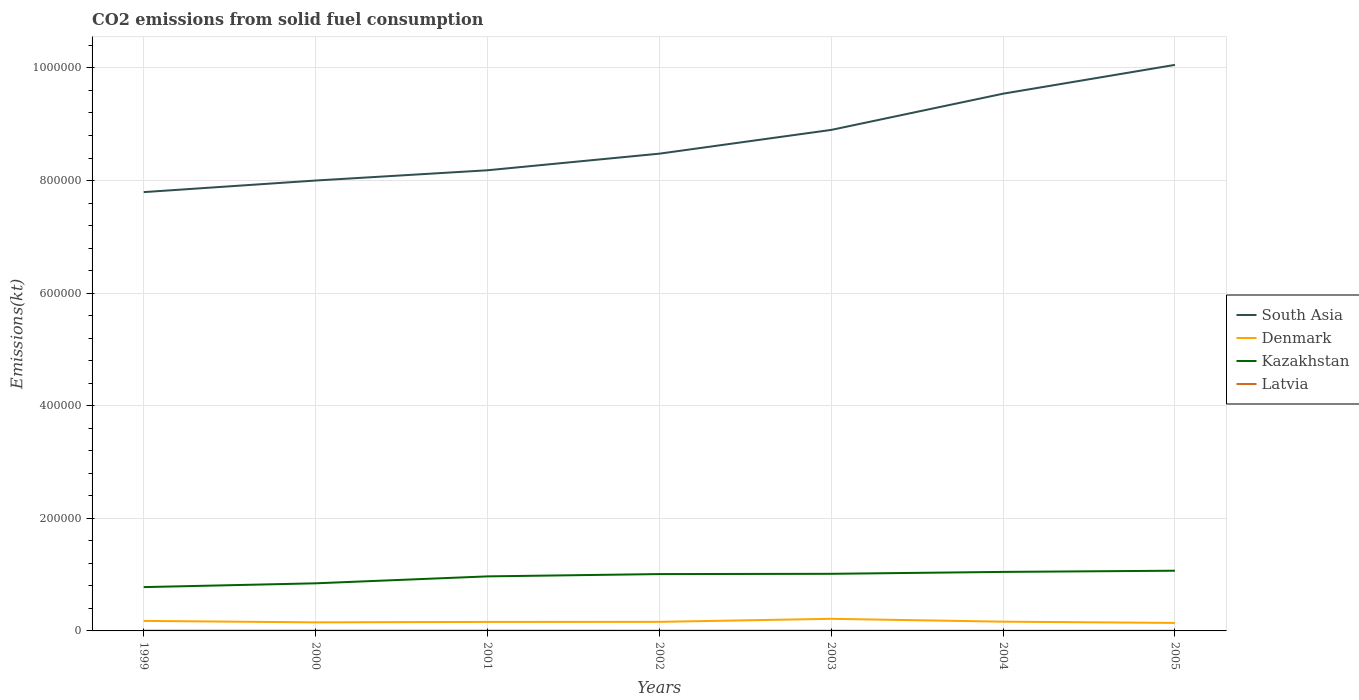How many different coloured lines are there?
Your response must be concise. 4. Does the line corresponding to Kazakhstan intersect with the line corresponding to Latvia?
Offer a terse response. No. Is the number of lines equal to the number of legend labels?
Offer a terse response. Yes. Across all years, what is the maximum amount of CO2 emitted in Kazakhstan?
Give a very brief answer. 7.78e+04. In which year was the amount of CO2 emitted in Denmark maximum?
Give a very brief answer. 2005. What is the total amount of CO2 emitted in Latvia in the graph?
Your response must be concise. 121.01. What is the difference between the highest and the second highest amount of CO2 emitted in Kazakhstan?
Ensure brevity in your answer.  2.91e+04. Is the amount of CO2 emitted in Denmark strictly greater than the amount of CO2 emitted in Kazakhstan over the years?
Keep it short and to the point. Yes. How many lines are there?
Make the answer very short. 4. What is the difference between two consecutive major ticks on the Y-axis?
Your response must be concise. 2.00e+05. How are the legend labels stacked?
Your response must be concise. Vertical. What is the title of the graph?
Keep it short and to the point. CO2 emissions from solid fuel consumption. What is the label or title of the Y-axis?
Your answer should be compact. Emissions(kt). What is the Emissions(kt) in South Asia in 1999?
Provide a short and direct response. 7.79e+05. What is the Emissions(kt) of Denmark in 1999?
Give a very brief answer. 1.78e+04. What is the Emissions(kt) in Kazakhstan in 1999?
Provide a succinct answer. 7.78e+04. What is the Emissions(kt) of Latvia in 1999?
Offer a very short reply. 480.38. What is the Emissions(kt) of South Asia in 2000?
Provide a succinct answer. 8.00e+05. What is the Emissions(kt) in Denmark in 2000?
Your answer should be compact. 1.52e+04. What is the Emissions(kt) in Kazakhstan in 2000?
Keep it short and to the point. 8.46e+04. What is the Emissions(kt) in Latvia in 2000?
Your response must be concise. 498.71. What is the Emissions(kt) in South Asia in 2001?
Offer a very short reply. 8.18e+05. What is the Emissions(kt) in Denmark in 2001?
Ensure brevity in your answer.  1.60e+04. What is the Emissions(kt) of Kazakhstan in 2001?
Provide a short and direct response. 9.69e+04. What is the Emissions(kt) in Latvia in 2001?
Give a very brief answer. 469.38. What is the Emissions(kt) in South Asia in 2002?
Your answer should be compact. 8.48e+05. What is the Emissions(kt) in Denmark in 2002?
Provide a succinct answer. 1.61e+04. What is the Emissions(kt) of Kazakhstan in 2002?
Ensure brevity in your answer.  1.01e+05. What is the Emissions(kt) in Latvia in 2002?
Give a very brief answer. 377.7. What is the Emissions(kt) of South Asia in 2003?
Your response must be concise. 8.90e+05. What is the Emissions(kt) in Denmark in 2003?
Give a very brief answer. 2.15e+04. What is the Emissions(kt) in Kazakhstan in 2003?
Provide a short and direct response. 1.01e+05. What is the Emissions(kt) in Latvia in 2003?
Your response must be concise. 330.03. What is the Emissions(kt) in South Asia in 2004?
Your response must be concise. 9.54e+05. What is the Emissions(kt) of Denmark in 2004?
Give a very brief answer. 1.64e+04. What is the Emissions(kt) in Kazakhstan in 2004?
Your response must be concise. 1.05e+05. What is the Emissions(kt) of Latvia in 2004?
Your answer should be compact. 256.69. What is the Emissions(kt) in South Asia in 2005?
Your response must be concise. 1.01e+06. What is the Emissions(kt) in Denmark in 2005?
Provide a succinct answer. 1.42e+04. What is the Emissions(kt) of Kazakhstan in 2005?
Give a very brief answer. 1.07e+05. What is the Emissions(kt) in Latvia in 2005?
Your answer should be compact. 311.69. Across all years, what is the maximum Emissions(kt) in South Asia?
Offer a very short reply. 1.01e+06. Across all years, what is the maximum Emissions(kt) in Denmark?
Offer a terse response. 2.15e+04. Across all years, what is the maximum Emissions(kt) of Kazakhstan?
Keep it short and to the point. 1.07e+05. Across all years, what is the maximum Emissions(kt) of Latvia?
Your answer should be very brief. 498.71. Across all years, what is the minimum Emissions(kt) of South Asia?
Offer a terse response. 7.79e+05. Across all years, what is the minimum Emissions(kt) of Denmark?
Your answer should be very brief. 1.42e+04. Across all years, what is the minimum Emissions(kt) in Kazakhstan?
Offer a very short reply. 7.78e+04. Across all years, what is the minimum Emissions(kt) of Latvia?
Make the answer very short. 256.69. What is the total Emissions(kt) of South Asia in the graph?
Keep it short and to the point. 6.10e+06. What is the total Emissions(kt) of Denmark in the graph?
Give a very brief answer. 1.17e+05. What is the total Emissions(kt) of Kazakhstan in the graph?
Provide a succinct answer. 6.73e+05. What is the total Emissions(kt) of Latvia in the graph?
Offer a terse response. 2724.58. What is the difference between the Emissions(kt) in South Asia in 1999 and that in 2000?
Provide a succinct answer. -2.06e+04. What is the difference between the Emissions(kt) of Denmark in 1999 and that in 2000?
Your answer should be very brief. 2592.57. What is the difference between the Emissions(kt) of Kazakhstan in 1999 and that in 2000?
Ensure brevity in your answer.  -6728.94. What is the difference between the Emissions(kt) in Latvia in 1999 and that in 2000?
Ensure brevity in your answer.  -18.34. What is the difference between the Emissions(kt) in South Asia in 1999 and that in 2001?
Make the answer very short. -3.88e+04. What is the difference between the Emissions(kt) of Denmark in 1999 and that in 2001?
Provide a succinct answer. 1826.17. What is the difference between the Emissions(kt) of Kazakhstan in 1999 and that in 2001?
Your answer should be compact. -1.90e+04. What is the difference between the Emissions(kt) in Latvia in 1999 and that in 2001?
Your response must be concise. 11. What is the difference between the Emissions(kt) of South Asia in 1999 and that in 2002?
Make the answer very short. -6.83e+04. What is the difference between the Emissions(kt) of Denmark in 1999 and that in 2002?
Offer a very short reply. 1679.49. What is the difference between the Emissions(kt) in Kazakhstan in 1999 and that in 2002?
Ensure brevity in your answer.  -2.31e+04. What is the difference between the Emissions(kt) in Latvia in 1999 and that in 2002?
Provide a short and direct response. 102.68. What is the difference between the Emissions(kt) in South Asia in 1999 and that in 2003?
Provide a succinct answer. -1.10e+05. What is the difference between the Emissions(kt) of Denmark in 1999 and that in 2003?
Provide a succinct answer. -3703.67. What is the difference between the Emissions(kt) of Kazakhstan in 1999 and that in 2003?
Offer a very short reply. -2.36e+04. What is the difference between the Emissions(kt) in Latvia in 1999 and that in 2003?
Make the answer very short. 150.35. What is the difference between the Emissions(kt) in South Asia in 1999 and that in 2004?
Your response must be concise. -1.75e+05. What is the difference between the Emissions(kt) of Denmark in 1999 and that in 2004?
Ensure brevity in your answer.  1364.12. What is the difference between the Emissions(kt) of Kazakhstan in 1999 and that in 2004?
Offer a very short reply. -2.70e+04. What is the difference between the Emissions(kt) of Latvia in 1999 and that in 2004?
Your response must be concise. 223.69. What is the difference between the Emissions(kt) in South Asia in 1999 and that in 2005?
Give a very brief answer. -2.26e+05. What is the difference between the Emissions(kt) in Denmark in 1999 and that in 2005?
Provide a short and direct response. 3600.99. What is the difference between the Emissions(kt) of Kazakhstan in 1999 and that in 2005?
Keep it short and to the point. -2.91e+04. What is the difference between the Emissions(kt) in Latvia in 1999 and that in 2005?
Your response must be concise. 168.68. What is the difference between the Emissions(kt) in South Asia in 2000 and that in 2001?
Provide a succinct answer. -1.82e+04. What is the difference between the Emissions(kt) of Denmark in 2000 and that in 2001?
Ensure brevity in your answer.  -766.4. What is the difference between the Emissions(kt) of Kazakhstan in 2000 and that in 2001?
Provide a short and direct response. -1.23e+04. What is the difference between the Emissions(kt) of Latvia in 2000 and that in 2001?
Provide a short and direct response. 29.34. What is the difference between the Emissions(kt) in South Asia in 2000 and that in 2002?
Give a very brief answer. -4.77e+04. What is the difference between the Emissions(kt) in Denmark in 2000 and that in 2002?
Give a very brief answer. -913.08. What is the difference between the Emissions(kt) of Kazakhstan in 2000 and that in 2002?
Your answer should be very brief. -1.64e+04. What is the difference between the Emissions(kt) of Latvia in 2000 and that in 2002?
Ensure brevity in your answer.  121.01. What is the difference between the Emissions(kt) in South Asia in 2000 and that in 2003?
Make the answer very short. -8.99e+04. What is the difference between the Emissions(kt) of Denmark in 2000 and that in 2003?
Keep it short and to the point. -6296.24. What is the difference between the Emissions(kt) of Kazakhstan in 2000 and that in 2003?
Offer a very short reply. -1.69e+04. What is the difference between the Emissions(kt) of Latvia in 2000 and that in 2003?
Your answer should be compact. 168.68. What is the difference between the Emissions(kt) of South Asia in 2000 and that in 2004?
Your response must be concise. -1.54e+05. What is the difference between the Emissions(kt) of Denmark in 2000 and that in 2004?
Offer a very short reply. -1228.44. What is the difference between the Emissions(kt) of Kazakhstan in 2000 and that in 2004?
Your response must be concise. -2.03e+04. What is the difference between the Emissions(kt) of Latvia in 2000 and that in 2004?
Offer a terse response. 242.02. What is the difference between the Emissions(kt) of South Asia in 2000 and that in 2005?
Ensure brevity in your answer.  -2.05e+05. What is the difference between the Emissions(kt) of Denmark in 2000 and that in 2005?
Your response must be concise. 1008.42. What is the difference between the Emissions(kt) in Kazakhstan in 2000 and that in 2005?
Make the answer very short. -2.24e+04. What is the difference between the Emissions(kt) in Latvia in 2000 and that in 2005?
Provide a short and direct response. 187.02. What is the difference between the Emissions(kt) in South Asia in 2001 and that in 2002?
Your answer should be compact. -2.95e+04. What is the difference between the Emissions(kt) of Denmark in 2001 and that in 2002?
Provide a short and direct response. -146.68. What is the difference between the Emissions(kt) in Kazakhstan in 2001 and that in 2002?
Make the answer very short. -4092.37. What is the difference between the Emissions(kt) of Latvia in 2001 and that in 2002?
Provide a short and direct response. 91.67. What is the difference between the Emissions(kt) of South Asia in 2001 and that in 2003?
Offer a very short reply. -7.17e+04. What is the difference between the Emissions(kt) in Denmark in 2001 and that in 2003?
Your answer should be compact. -5529.84. What is the difference between the Emissions(kt) of Kazakhstan in 2001 and that in 2003?
Make the answer very short. -4558.08. What is the difference between the Emissions(kt) in Latvia in 2001 and that in 2003?
Keep it short and to the point. 139.35. What is the difference between the Emissions(kt) of South Asia in 2001 and that in 2004?
Make the answer very short. -1.36e+05. What is the difference between the Emissions(kt) in Denmark in 2001 and that in 2004?
Your response must be concise. -462.04. What is the difference between the Emissions(kt) of Kazakhstan in 2001 and that in 2004?
Make the answer very short. -7950.06. What is the difference between the Emissions(kt) in Latvia in 2001 and that in 2004?
Your answer should be compact. 212.69. What is the difference between the Emissions(kt) in South Asia in 2001 and that in 2005?
Make the answer very short. -1.87e+05. What is the difference between the Emissions(kt) in Denmark in 2001 and that in 2005?
Provide a succinct answer. 1774.83. What is the difference between the Emissions(kt) in Kazakhstan in 2001 and that in 2005?
Give a very brief answer. -1.01e+04. What is the difference between the Emissions(kt) of Latvia in 2001 and that in 2005?
Offer a terse response. 157.68. What is the difference between the Emissions(kt) in South Asia in 2002 and that in 2003?
Your answer should be very brief. -4.22e+04. What is the difference between the Emissions(kt) of Denmark in 2002 and that in 2003?
Offer a terse response. -5383.16. What is the difference between the Emissions(kt) of Kazakhstan in 2002 and that in 2003?
Provide a succinct answer. -465.71. What is the difference between the Emissions(kt) in Latvia in 2002 and that in 2003?
Ensure brevity in your answer.  47.67. What is the difference between the Emissions(kt) of South Asia in 2002 and that in 2004?
Offer a terse response. -1.07e+05. What is the difference between the Emissions(kt) in Denmark in 2002 and that in 2004?
Offer a very short reply. -315.36. What is the difference between the Emissions(kt) of Kazakhstan in 2002 and that in 2004?
Provide a succinct answer. -3857.68. What is the difference between the Emissions(kt) of Latvia in 2002 and that in 2004?
Ensure brevity in your answer.  121.01. What is the difference between the Emissions(kt) in South Asia in 2002 and that in 2005?
Make the answer very short. -1.58e+05. What is the difference between the Emissions(kt) of Denmark in 2002 and that in 2005?
Provide a succinct answer. 1921.51. What is the difference between the Emissions(kt) in Kazakhstan in 2002 and that in 2005?
Provide a short and direct response. -5966.21. What is the difference between the Emissions(kt) of Latvia in 2002 and that in 2005?
Make the answer very short. 66.01. What is the difference between the Emissions(kt) of South Asia in 2003 and that in 2004?
Keep it short and to the point. -6.43e+04. What is the difference between the Emissions(kt) of Denmark in 2003 and that in 2004?
Your answer should be very brief. 5067.79. What is the difference between the Emissions(kt) in Kazakhstan in 2003 and that in 2004?
Your response must be concise. -3391.97. What is the difference between the Emissions(kt) in Latvia in 2003 and that in 2004?
Keep it short and to the point. 73.34. What is the difference between the Emissions(kt) of South Asia in 2003 and that in 2005?
Offer a very short reply. -1.16e+05. What is the difference between the Emissions(kt) of Denmark in 2003 and that in 2005?
Your answer should be compact. 7304.66. What is the difference between the Emissions(kt) of Kazakhstan in 2003 and that in 2005?
Offer a terse response. -5500.5. What is the difference between the Emissions(kt) of Latvia in 2003 and that in 2005?
Your answer should be very brief. 18.34. What is the difference between the Emissions(kt) of South Asia in 2004 and that in 2005?
Your response must be concise. -5.12e+04. What is the difference between the Emissions(kt) of Denmark in 2004 and that in 2005?
Offer a terse response. 2236.87. What is the difference between the Emissions(kt) in Kazakhstan in 2004 and that in 2005?
Provide a succinct answer. -2108.53. What is the difference between the Emissions(kt) in Latvia in 2004 and that in 2005?
Offer a terse response. -55.01. What is the difference between the Emissions(kt) in South Asia in 1999 and the Emissions(kt) in Denmark in 2000?
Your response must be concise. 7.64e+05. What is the difference between the Emissions(kt) of South Asia in 1999 and the Emissions(kt) of Kazakhstan in 2000?
Your answer should be compact. 6.95e+05. What is the difference between the Emissions(kt) of South Asia in 1999 and the Emissions(kt) of Latvia in 2000?
Your answer should be very brief. 7.79e+05. What is the difference between the Emissions(kt) in Denmark in 1999 and the Emissions(kt) in Kazakhstan in 2000?
Make the answer very short. -6.68e+04. What is the difference between the Emissions(kt) of Denmark in 1999 and the Emissions(kt) of Latvia in 2000?
Offer a terse response. 1.73e+04. What is the difference between the Emissions(kt) in Kazakhstan in 1999 and the Emissions(kt) in Latvia in 2000?
Provide a short and direct response. 7.73e+04. What is the difference between the Emissions(kt) of South Asia in 1999 and the Emissions(kt) of Denmark in 2001?
Your answer should be compact. 7.64e+05. What is the difference between the Emissions(kt) of South Asia in 1999 and the Emissions(kt) of Kazakhstan in 2001?
Your answer should be compact. 6.83e+05. What is the difference between the Emissions(kt) in South Asia in 1999 and the Emissions(kt) in Latvia in 2001?
Offer a very short reply. 7.79e+05. What is the difference between the Emissions(kt) in Denmark in 1999 and the Emissions(kt) in Kazakhstan in 2001?
Keep it short and to the point. -7.91e+04. What is the difference between the Emissions(kt) of Denmark in 1999 and the Emissions(kt) of Latvia in 2001?
Keep it short and to the point. 1.73e+04. What is the difference between the Emissions(kt) in Kazakhstan in 1999 and the Emissions(kt) in Latvia in 2001?
Provide a succinct answer. 7.74e+04. What is the difference between the Emissions(kt) in South Asia in 1999 and the Emissions(kt) in Denmark in 2002?
Your answer should be compact. 7.63e+05. What is the difference between the Emissions(kt) of South Asia in 1999 and the Emissions(kt) of Kazakhstan in 2002?
Give a very brief answer. 6.79e+05. What is the difference between the Emissions(kt) in South Asia in 1999 and the Emissions(kt) in Latvia in 2002?
Offer a very short reply. 7.79e+05. What is the difference between the Emissions(kt) of Denmark in 1999 and the Emissions(kt) of Kazakhstan in 2002?
Give a very brief answer. -8.32e+04. What is the difference between the Emissions(kt) in Denmark in 1999 and the Emissions(kt) in Latvia in 2002?
Offer a terse response. 1.74e+04. What is the difference between the Emissions(kt) of Kazakhstan in 1999 and the Emissions(kt) of Latvia in 2002?
Offer a terse response. 7.75e+04. What is the difference between the Emissions(kt) of South Asia in 1999 and the Emissions(kt) of Denmark in 2003?
Offer a very short reply. 7.58e+05. What is the difference between the Emissions(kt) of South Asia in 1999 and the Emissions(kt) of Kazakhstan in 2003?
Offer a very short reply. 6.78e+05. What is the difference between the Emissions(kt) in South Asia in 1999 and the Emissions(kt) in Latvia in 2003?
Your answer should be very brief. 7.79e+05. What is the difference between the Emissions(kt) of Denmark in 1999 and the Emissions(kt) of Kazakhstan in 2003?
Give a very brief answer. -8.36e+04. What is the difference between the Emissions(kt) in Denmark in 1999 and the Emissions(kt) in Latvia in 2003?
Your response must be concise. 1.75e+04. What is the difference between the Emissions(kt) in Kazakhstan in 1999 and the Emissions(kt) in Latvia in 2003?
Your answer should be very brief. 7.75e+04. What is the difference between the Emissions(kt) of South Asia in 1999 and the Emissions(kt) of Denmark in 2004?
Offer a terse response. 7.63e+05. What is the difference between the Emissions(kt) in South Asia in 1999 and the Emissions(kt) in Kazakhstan in 2004?
Make the answer very short. 6.75e+05. What is the difference between the Emissions(kt) in South Asia in 1999 and the Emissions(kt) in Latvia in 2004?
Offer a terse response. 7.79e+05. What is the difference between the Emissions(kt) of Denmark in 1999 and the Emissions(kt) of Kazakhstan in 2004?
Provide a succinct answer. -8.70e+04. What is the difference between the Emissions(kt) in Denmark in 1999 and the Emissions(kt) in Latvia in 2004?
Your answer should be compact. 1.75e+04. What is the difference between the Emissions(kt) in Kazakhstan in 1999 and the Emissions(kt) in Latvia in 2004?
Offer a terse response. 7.76e+04. What is the difference between the Emissions(kt) in South Asia in 1999 and the Emissions(kt) in Denmark in 2005?
Your response must be concise. 7.65e+05. What is the difference between the Emissions(kt) in South Asia in 1999 and the Emissions(kt) in Kazakhstan in 2005?
Offer a terse response. 6.73e+05. What is the difference between the Emissions(kt) of South Asia in 1999 and the Emissions(kt) of Latvia in 2005?
Your response must be concise. 7.79e+05. What is the difference between the Emissions(kt) of Denmark in 1999 and the Emissions(kt) of Kazakhstan in 2005?
Provide a succinct answer. -8.91e+04. What is the difference between the Emissions(kt) of Denmark in 1999 and the Emissions(kt) of Latvia in 2005?
Make the answer very short. 1.75e+04. What is the difference between the Emissions(kt) of Kazakhstan in 1999 and the Emissions(kt) of Latvia in 2005?
Give a very brief answer. 7.75e+04. What is the difference between the Emissions(kt) in South Asia in 2000 and the Emissions(kt) in Denmark in 2001?
Offer a very short reply. 7.84e+05. What is the difference between the Emissions(kt) of South Asia in 2000 and the Emissions(kt) of Kazakhstan in 2001?
Offer a very short reply. 7.03e+05. What is the difference between the Emissions(kt) in South Asia in 2000 and the Emissions(kt) in Latvia in 2001?
Give a very brief answer. 8.00e+05. What is the difference between the Emissions(kt) in Denmark in 2000 and the Emissions(kt) in Kazakhstan in 2001?
Keep it short and to the point. -8.17e+04. What is the difference between the Emissions(kt) in Denmark in 2000 and the Emissions(kt) in Latvia in 2001?
Your response must be concise. 1.47e+04. What is the difference between the Emissions(kt) of Kazakhstan in 2000 and the Emissions(kt) of Latvia in 2001?
Offer a very short reply. 8.41e+04. What is the difference between the Emissions(kt) of South Asia in 2000 and the Emissions(kt) of Denmark in 2002?
Your answer should be compact. 7.84e+05. What is the difference between the Emissions(kt) of South Asia in 2000 and the Emissions(kt) of Kazakhstan in 2002?
Keep it short and to the point. 6.99e+05. What is the difference between the Emissions(kt) of South Asia in 2000 and the Emissions(kt) of Latvia in 2002?
Offer a very short reply. 8.00e+05. What is the difference between the Emissions(kt) in Denmark in 2000 and the Emissions(kt) in Kazakhstan in 2002?
Provide a short and direct response. -8.58e+04. What is the difference between the Emissions(kt) in Denmark in 2000 and the Emissions(kt) in Latvia in 2002?
Make the answer very short. 1.48e+04. What is the difference between the Emissions(kt) in Kazakhstan in 2000 and the Emissions(kt) in Latvia in 2002?
Make the answer very short. 8.42e+04. What is the difference between the Emissions(kt) of South Asia in 2000 and the Emissions(kt) of Denmark in 2003?
Your response must be concise. 7.79e+05. What is the difference between the Emissions(kt) in South Asia in 2000 and the Emissions(kt) in Kazakhstan in 2003?
Your answer should be very brief. 6.99e+05. What is the difference between the Emissions(kt) of South Asia in 2000 and the Emissions(kt) of Latvia in 2003?
Make the answer very short. 8.00e+05. What is the difference between the Emissions(kt) in Denmark in 2000 and the Emissions(kt) in Kazakhstan in 2003?
Your answer should be very brief. -8.62e+04. What is the difference between the Emissions(kt) in Denmark in 2000 and the Emissions(kt) in Latvia in 2003?
Make the answer very short. 1.49e+04. What is the difference between the Emissions(kt) of Kazakhstan in 2000 and the Emissions(kt) of Latvia in 2003?
Your answer should be compact. 8.42e+04. What is the difference between the Emissions(kt) in South Asia in 2000 and the Emissions(kt) in Denmark in 2004?
Your answer should be very brief. 7.84e+05. What is the difference between the Emissions(kt) of South Asia in 2000 and the Emissions(kt) of Kazakhstan in 2004?
Offer a very short reply. 6.95e+05. What is the difference between the Emissions(kt) in South Asia in 2000 and the Emissions(kt) in Latvia in 2004?
Provide a succinct answer. 8.00e+05. What is the difference between the Emissions(kt) of Denmark in 2000 and the Emissions(kt) of Kazakhstan in 2004?
Ensure brevity in your answer.  -8.96e+04. What is the difference between the Emissions(kt) in Denmark in 2000 and the Emissions(kt) in Latvia in 2004?
Your response must be concise. 1.50e+04. What is the difference between the Emissions(kt) of Kazakhstan in 2000 and the Emissions(kt) of Latvia in 2004?
Give a very brief answer. 8.43e+04. What is the difference between the Emissions(kt) in South Asia in 2000 and the Emissions(kt) in Denmark in 2005?
Keep it short and to the point. 7.86e+05. What is the difference between the Emissions(kt) in South Asia in 2000 and the Emissions(kt) in Kazakhstan in 2005?
Give a very brief answer. 6.93e+05. What is the difference between the Emissions(kt) of South Asia in 2000 and the Emissions(kt) of Latvia in 2005?
Make the answer very short. 8.00e+05. What is the difference between the Emissions(kt) of Denmark in 2000 and the Emissions(kt) of Kazakhstan in 2005?
Ensure brevity in your answer.  -9.17e+04. What is the difference between the Emissions(kt) of Denmark in 2000 and the Emissions(kt) of Latvia in 2005?
Provide a short and direct response. 1.49e+04. What is the difference between the Emissions(kt) in Kazakhstan in 2000 and the Emissions(kt) in Latvia in 2005?
Give a very brief answer. 8.43e+04. What is the difference between the Emissions(kt) in South Asia in 2001 and the Emissions(kt) in Denmark in 2002?
Make the answer very short. 8.02e+05. What is the difference between the Emissions(kt) of South Asia in 2001 and the Emissions(kt) of Kazakhstan in 2002?
Ensure brevity in your answer.  7.17e+05. What is the difference between the Emissions(kt) in South Asia in 2001 and the Emissions(kt) in Latvia in 2002?
Give a very brief answer. 8.18e+05. What is the difference between the Emissions(kt) in Denmark in 2001 and the Emissions(kt) in Kazakhstan in 2002?
Keep it short and to the point. -8.50e+04. What is the difference between the Emissions(kt) in Denmark in 2001 and the Emissions(kt) in Latvia in 2002?
Ensure brevity in your answer.  1.56e+04. What is the difference between the Emissions(kt) of Kazakhstan in 2001 and the Emissions(kt) of Latvia in 2002?
Make the answer very short. 9.65e+04. What is the difference between the Emissions(kt) in South Asia in 2001 and the Emissions(kt) in Denmark in 2003?
Your answer should be compact. 7.97e+05. What is the difference between the Emissions(kt) in South Asia in 2001 and the Emissions(kt) in Kazakhstan in 2003?
Provide a short and direct response. 7.17e+05. What is the difference between the Emissions(kt) in South Asia in 2001 and the Emissions(kt) in Latvia in 2003?
Provide a succinct answer. 8.18e+05. What is the difference between the Emissions(kt) of Denmark in 2001 and the Emissions(kt) of Kazakhstan in 2003?
Offer a very short reply. -8.55e+04. What is the difference between the Emissions(kt) in Denmark in 2001 and the Emissions(kt) in Latvia in 2003?
Make the answer very short. 1.56e+04. What is the difference between the Emissions(kt) of Kazakhstan in 2001 and the Emissions(kt) of Latvia in 2003?
Offer a very short reply. 9.65e+04. What is the difference between the Emissions(kt) in South Asia in 2001 and the Emissions(kt) in Denmark in 2004?
Your response must be concise. 8.02e+05. What is the difference between the Emissions(kt) of South Asia in 2001 and the Emissions(kt) of Kazakhstan in 2004?
Provide a short and direct response. 7.13e+05. What is the difference between the Emissions(kt) in South Asia in 2001 and the Emissions(kt) in Latvia in 2004?
Ensure brevity in your answer.  8.18e+05. What is the difference between the Emissions(kt) in Denmark in 2001 and the Emissions(kt) in Kazakhstan in 2004?
Make the answer very short. -8.89e+04. What is the difference between the Emissions(kt) of Denmark in 2001 and the Emissions(kt) of Latvia in 2004?
Offer a very short reply. 1.57e+04. What is the difference between the Emissions(kt) in Kazakhstan in 2001 and the Emissions(kt) in Latvia in 2004?
Offer a very short reply. 9.66e+04. What is the difference between the Emissions(kt) of South Asia in 2001 and the Emissions(kt) of Denmark in 2005?
Your answer should be compact. 8.04e+05. What is the difference between the Emissions(kt) in South Asia in 2001 and the Emissions(kt) in Kazakhstan in 2005?
Offer a very short reply. 7.11e+05. What is the difference between the Emissions(kt) of South Asia in 2001 and the Emissions(kt) of Latvia in 2005?
Offer a very short reply. 8.18e+05. What is the difference between the Emissions(kt) of Denmark in 2001 and the Emissions(kt) of Kazakhstan in 2005?
Give a very brief answer. -9.10e+04. What is the difference between the Emissions(kt) in Denmark in 2001 and the Emissions(kt) in Latvia in 2005?
Ensure brevity in your answer.  1.57e+04. What is the difference between the Emissions(kt) of Kazakhstan in 2001 and the Emissions(kt) of Latvia in 2005?
Provide a short and direct response. 9.66e+04. What is the difference between the Emissions(kt) in South Asia in 2002 and the Emissions(kt) in Denmark in 2003?
Ensure brevity in your answer.  8.26e+05. What is the difference between the Emissions(kt) in South Asia in 2002 and the Emissions(kt) in Kazakhstan in 2003?
Give a very brief answer. 7.46e+05. What is the difference between the Emissions(kt) of South Asia in 2002 and the Emissions(kt) of Latvia in 2003?
Provide a short and direct response. 8.47e+05. What is the difference between the Emissions(kt) in Denmark in 2002 and the Emissions(kt) in Kazakhstan in 2003?
Give a very brief answer. -8.53e+04. What is the difference between the Emissions(kt) in Denmark in 2002 and the Emissions(kt) in Latvia in 2003?
Make the answer very short. 1.58e+04. What is the difference between the Emissions(kt) of Kazakhstan in 2002 and the Emissions(kt) of Latvia in 2003?
Offer a terse response. 1.01e+05. What is the difference between the Emissions(kt) of South Asia in 2002 and the Emissions(kt) of Denmark in 2004?
Your response must be concise. 8.31e+05. What is the difference between the Emissions(kt) in South Asia in 2002 and the Emissions(kt) in Kazakhstan in 2004?
Your response must be concise. 7.43e+05. What is the difference between the Emissions(kt) of South Asia in 2002 and the Emissions(kt) of Latvia in 2004?
Provide a short and direct response. 8.47e+05. What is the difference between the Emissions(kt) of Denmark in 2002 and the Emissions(kt) of Kazakhstan in 2004?
Keep it short and to the point. -8.87e+04. What is the difference between the Emissions(kt) of Denmark in 2002 and the Emissions(kt) of Latvia in 2004?
Your answer should be very brief. 1.59e+04. What is the difference between the Emissions(kt) in Kazakhstan in 2002 and the Emissions(kt) in Latvia in 2004?
Ensure brevity in your answer.  1.01e+05. What is the difference between the Emissions(kt) in South Asia in 2002 and the Emissions(kt) in Denmark in 2005?
Provide a succinct answer. 8.34e+05. What is the difference between the Emissions(kt) of South Asia in 2002 and the Emissions(kt) of Kazakhstan in 2005?
Make the answer very short. 7.41e+05. What is the difference between the Emissions(kt) of South Asia in 2002 and the Emissions(kt) of Latvia in 2005?
Your answer should be compact. 8.47e+05. What is the difference between the Emissions(kt) of Denmark in 2002 and the Emissions(kt) of Kazakhstan in 2005?
Provide a short and direct response. -9.08e+04. What is the difference between the Emissions(kt) in Denmark in 2002 and the Emissions(kt) in Latvia in 2005?
Ensure brevity in your answer.  1.58e+04. What is the difference between the Emissions(kt) in Kazakhstan in 2002 and the Emissions(kt) in Latvia in 2005?
Ensure brevity in your answer.  1.01e+05. What is the difference between the Emissions(kt) in South Asia in 2003 and the Emissions(kt) in Denmark in 2004?
Give a very brief answer. 8.74e+05. What is the difference between the Emissions(kt) of South Asia in 2003 and the Emissions(kt) of Kazakhstan in 2004?
Keep it short and to the point. 7.85e+05. What is the difference between the Emissions(kt) of South Asia in 2003 and the Emissions(kt) of Latvia in 2004?
Provide a short and direct response. 8.90e+05. What is the difference between the Emissions(kt) in Denmark in 2003 and the Emissions(kt) in Kazakhstan in 2004?
Provide a short and direct response. -8.33e+04. What is the difference between the Emissions(kt) of Denmark in 2003 and the Emissions(kt) of Latvia in 2004?
Make the answer very short. 2.12e+04. What is the difference between the Emissions(kt) in Kazakhstan in 2003 and the Emissions(kt) in Latvia in 2004?
Make the answer very short. 1.01e+05. What is the difference between the Emissions(kt) in South Asia in 2003 and the Emissions(kt) in Denmark in 2005?
Make the answer very short. 8.76e+05. What is the difference between the Emissions(kt) of South Asia in 2003 and the Emissions(kt) of Kazakhstan in 2005?
Give a very brief answer. 7.83e+05. What is the difference between the Emissions(kt) of South Asia in 2003 and the Emissions(kt) of Latvia in 2005?
Your answer should be very brief. 8.90e+05. What is the difference between the Emissions(kt) of Denmark in 2003 and the Emissions(kt) of Kazakhstan in 2005?
Ensure brevity in your answer.  -8.54e+04. What is the difference between the Emissions(kt) of Denmark in 2003 and the Emissions(kt) of Latvia in 2005?
Ensure brevity in your answer.  2.12e+04. What is the difference between the Emissions(kt) in Kazakhstan in 2003 and the Emissions(kt) in Latvia in 2005?
Your answer should be very brief. 1.01e+05. What is the difference between the Emissions(kt) of South Asia in 2004 and the Emissions(kt) of Denmark in 2005?
Make the answer very short. 9.40e+05. What is the difference between the Emissions(kt) of South Asia in 2004 and the Emissions(kt) of Kazakhstan in 2005?
Your response must be concise. 8.47e+05. What is the difference between the Emissions(kt) in South Asia in 2004 and the Emissions(kt) in Latvia in 2005?
Provide a short and direct response. 9.54e+05. What is the difference between the Emissions(kt) in Denmark in 2004 and the Emissions(kt) in Kazakhstan in 2005?
Keep it short and to the point. -9.05e+04. What is the difference between the Emissions(kt) in Denmark in 2004 and the Emissions(kt) in Latvia in 2005?
Provide a succinct answer. 1.61e+04. What is the difference between the Emissions(kt) of Kazakhstan in 2004 and the Emissions(kt) of Latvia in 2005?
Make the answer very short. 1.05e+05. What is the average Emissions(kt) in South Asia per year?
Offer a terse response. 8.71e+05. What is the average Emissions(kt) of Denmark per year?
Make the answer very short. 1.67e+04. What is the average Emissions(kt) in Kazakhstan per year?
Your response must be concise. 9.62e+04. What is the average Emissions(kt) in Latvia per year?
Ensure brevity in your answer.  389.23. In the year 1999, what is the difference between the Emissions(kt) of South Asia and Emissions(kt) of Denmark?
Give a very brief answer. 7.62e+05. In the year 1999, what is the difference between the Emissions(kt) of South Asia and Emissions(kt) of Kazakhstan?
Offer a terse response. 7.02e+05. In the year 1999, what is the difference between the Emissions(kt) in South Asia and Emissions(kt) in Latvia?
Ensure brevity in your answer.  7.79e+05. In the year 1999, what is the difference between the Emissions(kt) in Denmark and Emissions(kt) in Kazakhstan?
Keep it short and to the point. -6.00e+04. In the year 1999, what is the difference between the Emissions(kt) of Denmark and Emissions(kt) of Latvia?
Give a very brief answer. 1.73e+04. In the year 1999, what is the difference between the Emissions(kt) of Kazakhstan and Emissions(kt) of Latvia?
Give a very brief answer. 7.74e+04. In the year 2000, what is the difference between the Emissions(kt) of South Asia and Emissions(kt) of Denmark?
Offer a terse response. 7.85e+05. In the year 2000, what is the difference between the Emissions(kt) of South Asia and Emissions(kt) of Kazakhstan?
Provide a short and direct response. 7.15e+05. In the year 2000, what is the difference between the Emissions(kt) in South Asia and Emissions(kt) in Latvia?
Your response must be concise. 8.00e+05. In the year 2000, what is the difference between the Emissions(kt) in Denmark and Emissions(kt) in Kazakhstan?
Keep it short and to the point. -6.94e+04. In the year 2000, what is the difference between the Emissions(kt) in Denmark and Emissions(kt) in Latvia?
Your answer should be compact. 1.47e+04. In the year 2000, what is the difference between the Emissions(kt) in Kazakhstan and Emissions(kt) in Latvia?
Your answer should be compact. 8.41e+04. In the year 2001, what is the difference between the Emissions(kt) in South Asia and Emissions(kt) in Denmark?
Provide a succinct answer. 8.02e+05. In the year 2001, what is the difference between the Emissions(kt) in South Asia and Emissions(kt) in Kazakhstan?
Ensure brevity in your answer.  7.21e+05. In the year 2001, what is the difference between the Emissions(kt) in South Asia and Emissions(kt) in Latvia?
Your answer should be compact. 8.18e+05. In the year 2001, what is the difference between the Emissions(kt) in Denmark and Emissions(kt) in Kazakhstan?
Provide a succinct answer. -8.09e+04. In the year 2001, what is the difference between the Emissions(kt) of Denmark and Emissions(kt) of Latvia?
Give a very brief answer. 1.55e+04. In the year 2001, what is the difference between the Emissions(kt) of Kazakhstan and Emissions(kt) of Latvia?
Your response must be concise. 9.64e+04. In the year 2002, what is the difference between the Emissions(kt) of South Asia and Emissions(kt) of Denmark?
Ensure brevity in your answer.  8.32e+05. In the year 2002, what is the difference between the Emissions(kt) of South Asia and Emissions(kt) of Kazakhstan?
Your answer should be very brief. 7.47e+05. In the year 2002, what is the difference between the Emissions(kt) of South Asia and Emissions(kt) of Latvia?
Provide a short and direct response. 8.47e+05. In the year 2002, what is the difference between the Emissions(kt) in Denmark and Emissions(kt) in Kazakhstan?
Make the answer very short. -8.49e+04. In the year 2002, what is the difference between the Emissions(kt) of Denmark and Emissions(kt) of Latvia?
Your answer should be very brief. 1.57e+04. In the year 2002, what is the difference between the Emissions(kt) of Kazakhstan and Emissions(kt) of Latvia?
Give a very brief answer. 1.01e+05. In the year 2003, what is the difference between the Emissions(kt) in South Asia and Emissions(kt) in Denmark?
Ensure brevity in your answer.  8.68e+05. In the year 2003, what is the difference between the Emissions(kt) in South Asia and Emissions(kt) in Kazakhstan?
Provide a short and direct response. 7.89e+05. In the year 2003, what is the difference between the Emissions(kt) in South Asia and Emissions(kt) in Latvia?
Your answer should be very brief. 8.90e+05. In the year 2003, what is the difference between the Emissions(kt) in Denmark and Emissions(kt) in Kazakhstan?
Provide a succinct answer. -7.99e+04. In the year 2003, what is the difference between the Emissions(kt) in Denmark and Emissions(kt) in Latvia?
Ensure brevity in your answer.  2.12e+04. In the year 2003, what is the difference between the Emissions(kt) in Kazakhstan and Emissions(kt) in Latvia?
Your answer should be very brief. 1.01e+05. In the year 2004, what is the difference between the Emissions(kt) of South Asia and Emissions(kt) of Denmark?
Your answer should be very brief. 9.38e+05. In the year 2004, what is the difference between the Emissions(kt) in South Asia and Emissions(kt) in Kazakhstan?
Ensure brevity in your answer.  8.49e+05. In the year 2004, what is the difference between the Emissions(kt) in South Asia and Emissions(kt) in Latvia?
Provide a short and direct response. 9.54e+05. In the year 2004, what is the difference between the Emissions(kt) of Denmark and Emissions(kt) of Kazakhstan?
Your response must be concise. -8.84e+04. In the year 2004, what is the difference between the Emissions(kt) in Denmark and Emissions(kt) in Latvia?
Offer a terse response. 1.62e+04. In the year 2004, what is the difference between the Emissions(kt) in Kazakhstan and Emissions(kt) in Latvia?
Offer a terse response. 1.05e+05. In the year 2005, what is the difference between the Emissions(kt) in South Asia and Emissions(kt) in Denmark?
Give a very brief answer. 9.91e+05. In the year 2005, what is the difference between the Emissions(kt) of South Asia and Emissions(kt) of Kazakhstan?
Provide a succinct answer. 8.99e+05. In the year 2005, what is the difference between the Emissions(kt) of South Asia and Emissions(kt) of Latvia?
Provide a short and direct response. 1.01e+06. In the year 2005, what is the difference between the Emissions(kt) of Denmark and Emissions(kt) of Kazakhstan?
Your answer should be very brief. -9.27e+04. In the year 2005, what is the difference between the Emissions(kt) of Denmark and Emissions(kt) of Latvia?
Your response must be concise. 1.39e+04. In the year 2005, what is the difference between the Emissions(kt) of Kazakhstan and Emissions(kt) of Latvia?
Offer a very short reply. 1.07e+05. What is the ratio of the Emissions(kt) of South Asia in 1999 to that in 2000?
Give a very brief answer. 0.97. What is the ratio of the Emissions(kt) in Denmark in 1999 to that in 2000?
Offer a very short reply. 1.17. What is the ratio of the Emissions(kt) of Kazakhstan in 1999 to that in 2000?
Give a very brief answer. 0.92. What is the ratio of the Emissions(kt) of Latvia in 1999 to that in 2000?
Give a very brief answer. 0.96. What is the ratio of the Emissions(kt) in South Asia in 1999 to that in 2001?
Keep it short and to the point. 0.95. What is the ratio of the Emissions(kt) in Denmark in 1999 to that in 2001?
Your answer should be very brief. 1.11. What is the ratio of the Emissions(kt) in Kazakhstan in 1999 to that in 2001?
Offer a very short reply. 0.8. What is the ratio of the Emissions(kt) in Latvia in 1999 to that in 2001?
Provide a succinct answer. 1.02. What is the ratio of the Emissions(kt) in South Asia in 1999 to that in 2002?
Make the answer very short. 0.92. What is the ratio of the Emissions(kt) of Denmark in 1999 to that in 2002?
Make the answer very short. 1.1. What is the ratio of the Emissions(kt) in Kazakhstan in 1999 to that in 2002?
Give a very brief answer. 0.77. What is the ratio of the Emissions(kt) of Latvia in 1999 to that in 2002?
Provide a succinct answer. 1.27. What is the ratio of the Emissions(kt) in South Asia in 1999 to that in 2003?
Offer a terse response. 0.88. What is the ratio of the Emissions(kt) of Denmark in 1999 to that in 2003?
Keep it short and to the point. 0.83. What is the ratio of the Emissions(kt) in Kazakhstan in 1999 to that in 2003?
Provide a succinct answer. 0.77. What is the ratio of the Emissions(kt) in Latvia in 1999 to that in 2003?
Make the answer very short. 1.46. What is the ratio of the Emissions(kt) in South Asia in 1999 to that in 2004?
Keep it short and to the point. 0.82. What is the ratio of the Emissions(kt) of Denmark in 1999 to that in 2004?
Your response must be concise. 1.08. What is the ratio of the Emissions(kt) in Kazakhstan in 1999 to that in 2004?
Your response must be concise. 0.74. What is the ratio of the Emissions(kt) in Latvia in 1999 to that in 2004?
Offer a very short reply. 1.87. What is the ratio of the Emissions(kt) in South Asia in 1999 to that in 2005?
Your answer should be compact. 0.78. What is the ratio of the Emissions(kt) of Denmark in 1999 to that in 2005?
Your response must be concise. 1.25. What is the ratio of the Emissions(kt) of Kazakhstan in 1999 to that in 2005?
Provide a short and direct response. 0.73. What is the ratio of the Emissions(kt) in Latvia in 1999 to that in 2005?
Your answer should be compact. 1.54. What is the ratio of the Emissions(kt) of South Asia in 2000 to that in 2001?
Provide a succinct answer. 0.98. What is the ratio of the Emissions(kt) of Kazakhstan in 2000 to that in 2001?
Provide a succinct answer. 0.87. What is the ratio of the Emissions(kt) of Latvia in 2000 to that in 2001?
Make the answer very short. 1.06. What is the ratio of the Emissions(kt) in South Asia in 2000 to that in 2002?
Provide a succinct answer. 0.94. What is the ratio of the Emissions(kt) of Denmark in 2000 to that in 2002?
Provide a succinct answer. 0.94. What is the ratio of the Emissions(kt) of Kazakhstan in 2000 to that in 2002?
Offer a very short reply. 0.84. What is the ratio of the Emissions(kt) of Latvia in 2000 to that in 2002?
Offer a terse response. 1.32. What is the ratio of the Emissions(kt) of South Asia in 2000 to that in 2003?
Your answer should be compact. 0.9. What is the ratio of the Emissions(kt) of Denmark in 2000 to that in 2003?
Give a very brief answer. 0.71. What is the ratio of the Emissions(kt) in Kazakhstan in 2000 to that in 2003?
Your answer should be very brief. 0.83. What is the ratio of the Emissions(kt) in Latvia in 2000 to that in 2003?
Your answer should be compact. 1.51. What is the ratio of the Emissions(kt) in South Asia in 2000 to that in 2004?
Your answer should be very brief. 0.84. What is the ratio of the Emissions(kt) of Denmark in 2000 to that in 2004?
Provide a succinct answer. 0.93. What is the ratio of the Emissions(kt) of Kazakhstan in 2000 to that in 2004?
Make the answer very short. 0.81. What is the ratio of the Emissions(kt) of Latvia in 2000 to that in 2004?
Keep it short and to the point. 1.94. What is the ratio of the Emissions(kt) of South Asia in 2000 to that in 2005?
Offer a terse response. 0.8. What is the ratio of the Emissions(kt) of Denmark in 2000 to that in 2005?
Offer a very short reply. 1.07. What is the ratio of the Emissions(kt) of Kazakhstan in 2000 to that in 2005?
Your response must be concise. 0.79. What is the ratio of the Emissions(kt) in Latvia in 2000 to that in 2005?
Offer a terse response. 1.6. What is the ratio of the Emissions(kt) of South Asia in 2001 to that in 2002?
Your answer should be very brief. 0.97. What is the ratio of the Emissions(kt) of Denmark in 2001 to that in 2002?
Your answer should be compact. 0.99. What is the ratio of the Emissions(kt) in Kazakhstan in 2001 to that in 2002?
Ensure brevity in your answer.  0.96. What is the ratio of the Emissions(kt) in Latvia in 2001 to that in 2002?
Provide a succinct answer. 1.24. What is the ratio of the Emissions(kt) in South Asia in 2001 to that in 2003?
Keep it short and to the point. 0.92. What is the ratio of the Emissions(kt) in Denmark in 2001 to that in 2003?
Give a very brief answer. 0.74. What is the ratio of the Emissions(kt) of Kazakhstan in 2001 to that in 2003?
Your response must be concise. 0.96. What is the ratio of the Emissions(kt) in Latvia in 2001 to that in 2003?
Ensure brevity in your answer.  1.42. What is the ratio of the Emissions(kt) in South Asia in 2001 to that in 2004?
Offer a very short reply. 0.86. What is the ratio of the Emissions(kt) in Denmark in 2001 to that in 2004?
Offer a very short reply. 0.97. What is the ratio of the Emissions(kt) in Kazakhstan in 2001 to that in 2004?
Provide a short and direct response. 0.92. What is the ratio of the Emissions(kt) of Latvia in 2001 to that in 2004?
Give a very brief answer. 1.83. What is the ratio of the Emissions(kt) in South Asia in 2001 to that in 2005?
Offer a very short reply. 0.81. What is the ratio of the Emissions(kt) in Denmark in 2001 to that in 2005?
Ensure brevity in your answer.  1.12. What is the ratio of the Emissions(kt) in Kazakhstan in 2001 to that in 2005?
Keep it short and to the point. 0.91. What is the ratio of the Emissions(kt) in Latvia in 2001 to that in 2005?
Keep it short and to the point. 1.51. What is the ratio of the Emissions(kt) in South Asia in 2002 to that in 2003?
Ensure brevity in your answer.  0.95. What is the ratio of the Emissions(kt) of Denmark in 2002 to that in 2003?
Your answer should be very brief. 0.75. What is the ratio of the Emissions(kt) of Kazakhstan in 2002 to that in 2003?
Give a very brief answer. 1. What is the ratio of the Emissions(kt) of Latvia in 2002 to that in 2003?
Keep it short and to the point. 1.14. What is the ratio of the Emissions(kt) in South Asia in 2002 to that in 2004?
Your response must be concise. 0.89. What is the ratio of the Emissions(kt) in Denmark in 2002 to that in 2004?
Provide a short and direct response. 0.98. What is the ratio of the Emissions(kt) of Kazakhstan in 2002 to that in 2004?
Your response must be concise. 0.96. What is the ratio of the Emissions(kt) in Latvia in 2002 to that in 2004?
Keep it short and to the point. 1.47. What is the ratio of the Emissions(kt) of South Asia in 2002 to that in 2005?
Your answer should be very brief. 0.84. What is the ratio of the Emissions(kt) in Denmark in 2002 to that in 2005?
Your answer should be compact. 1.14. What is the ratio of the Emissions(kt) in Kazakhstan in 2002 to that in 2005?
Your answer should be very brief. 0.94. What is the ratio of the Emissions(kt) in Latvia in 2002 to that in 2005?
Your answer should be compact. 1.21. What is the ratio of the Emissions(kt) of South Asia in 2003 to that in 2004?
Provide a short and direct response. 0.93. What is the ratio of the Emissions(kt) of Denmark in 2003 to that in 2004?
Offer a very short reply. 1.31. What is the ratio of the Emissions(kt) of Kazakhstan in 2003 to that in 2004?
Your answer should be very brief. 0.97. What is the ratio of the Emissions(kt) in South Asia in 2003 to that in 2005?
Provide a succinct answer. 0.89. What is the ratio of the Emissions(kt) in Denmark in 2003 to that in 2005?
Your response must be concise. 1.51. What is the ratio of the Emissions(kt) of Kazakhstan in 2003 to that in 2005?
Provide a succinct answer. 0.95. What is the ratio of the Emissions(kt) of Latvia in 2003 to that in 2005?
Your answer should be compact. 1.06. What is the ratio of the Emissions(kt) in South Asia in 2004 to that in 2005?
Keep it short and to the point. 0.95. What is the ratio of the Emissions(kt) in Denmark in 2004 to that in 2005?
Provide a succinct answer. 1.16. What is the ratio of the Emissions(kt) in Kazakhstan in 2004 to that in 2005?
Your answer should be compact. 0.98. What is the ratio of the Emissions(kt) of Latvia in 2004 to that in 2005?
Keep it short and to the point. 0.82. What is the difference between the highest and the second highest Emissions(kt) in South Asia?
Provide a short and direct response. 5.12e+04. What is the difference between the highest and the second highest Emissions(kt) of Denmark?
Your response must be concise. 3703.67. What is the difference between the highest and the second highest Emissions(kt) in Kazakhstan?
Your answer should be very brief. 2108.53. What is the difference between the highest and the second highest Emissions(kt) in Latvia?
Make the answer very short. 18.34. What is the difference between the highest and the lowest Emissions(kt) in South Asia?
Keep it short and to the point. 2.26e+05. What is the difference between the highest and the lowest Emissions(kt) of Denmark?
Keep it short and to the point. 7304.66. What is the difference between the highest and the lowest Emissions(kt) in Kazakhstan?
Give a very brief answer. 2.91e+04. What is the difference between the highest and the lowest Emissions(kt) in Latvia?
Your response must be concise. 242.02. 